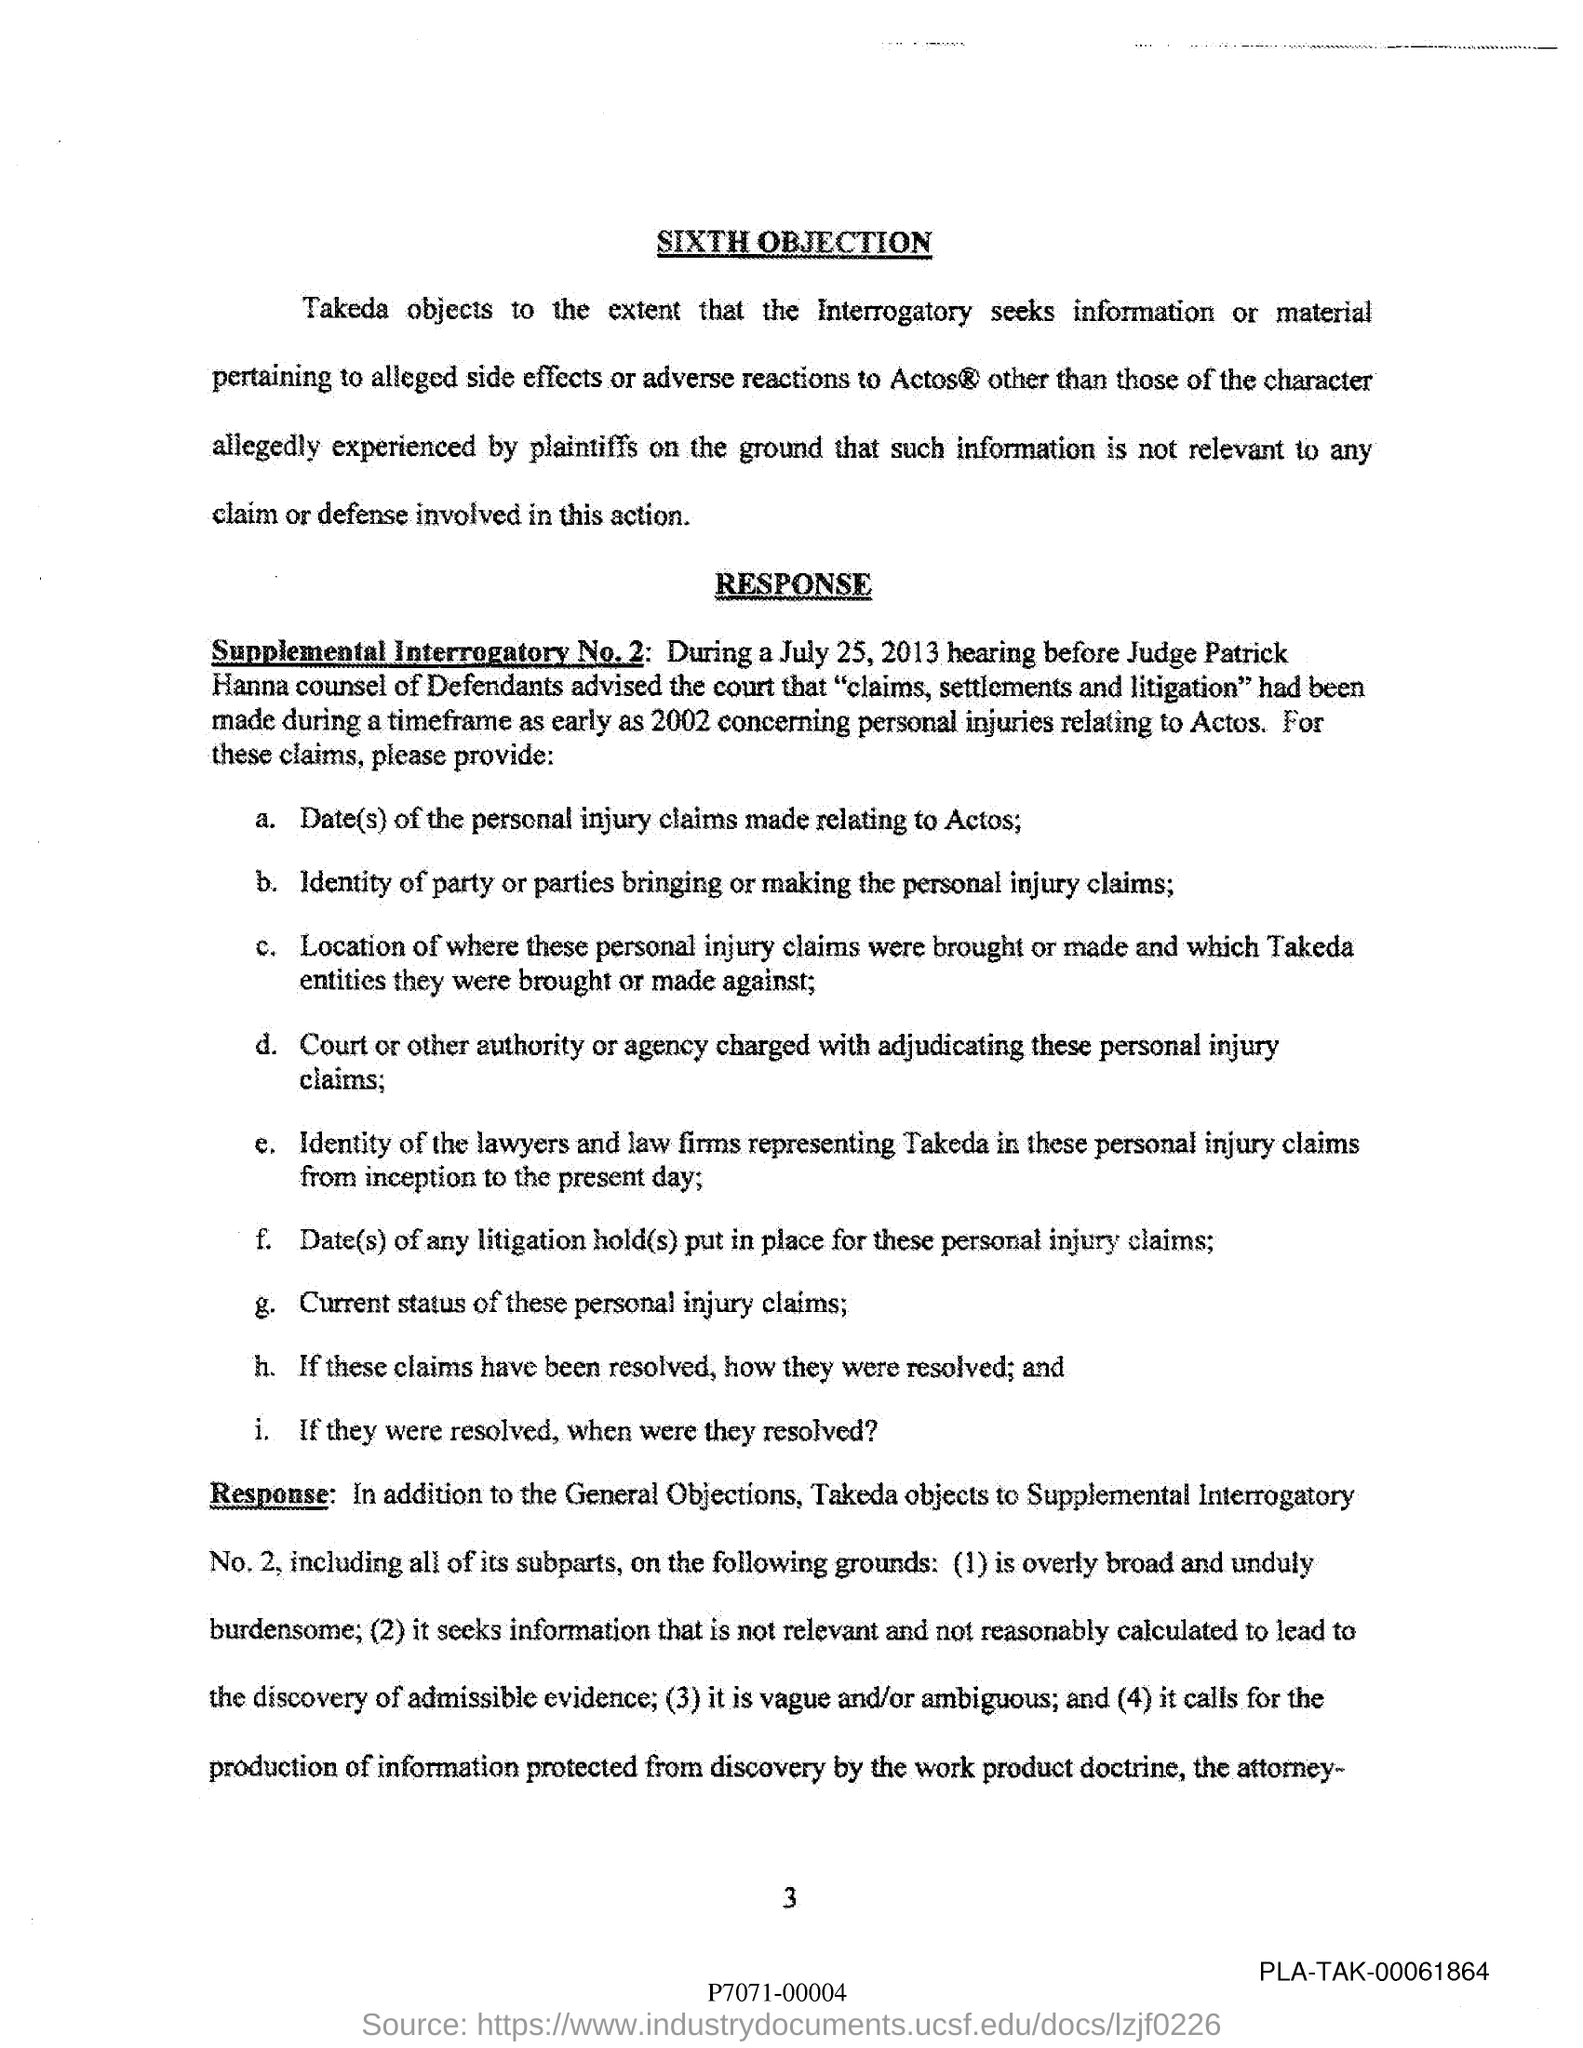Outline some significant characteristics in this image. The name of the judge is Patrick Hanna. What page number is mentioned in this document? It is page 3.. The hearing before Judge July 25, 2013 took place. The sixth objection to the guilt of the accused is as follows: [insert content of objection here]. 